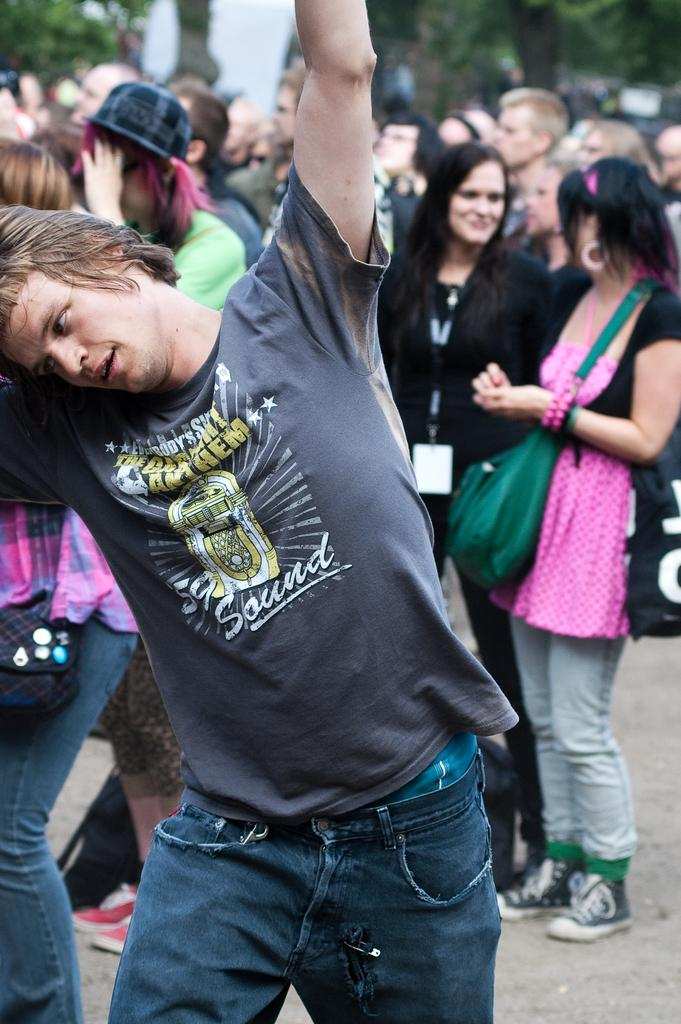What is the main subject in the front of the image? There is a person standing in the front of the image. What type of clothing is the person wearing? The person is wearing a t-shirt and jeans. Are there any other people visible in the image? Yes, there are other people visible in the image. What type of natural elements can be seen in the image? There are trees in the image. How many loaves of bread are being held by the kittens in the image? There are no kittens or loaves of bread present in the image. 